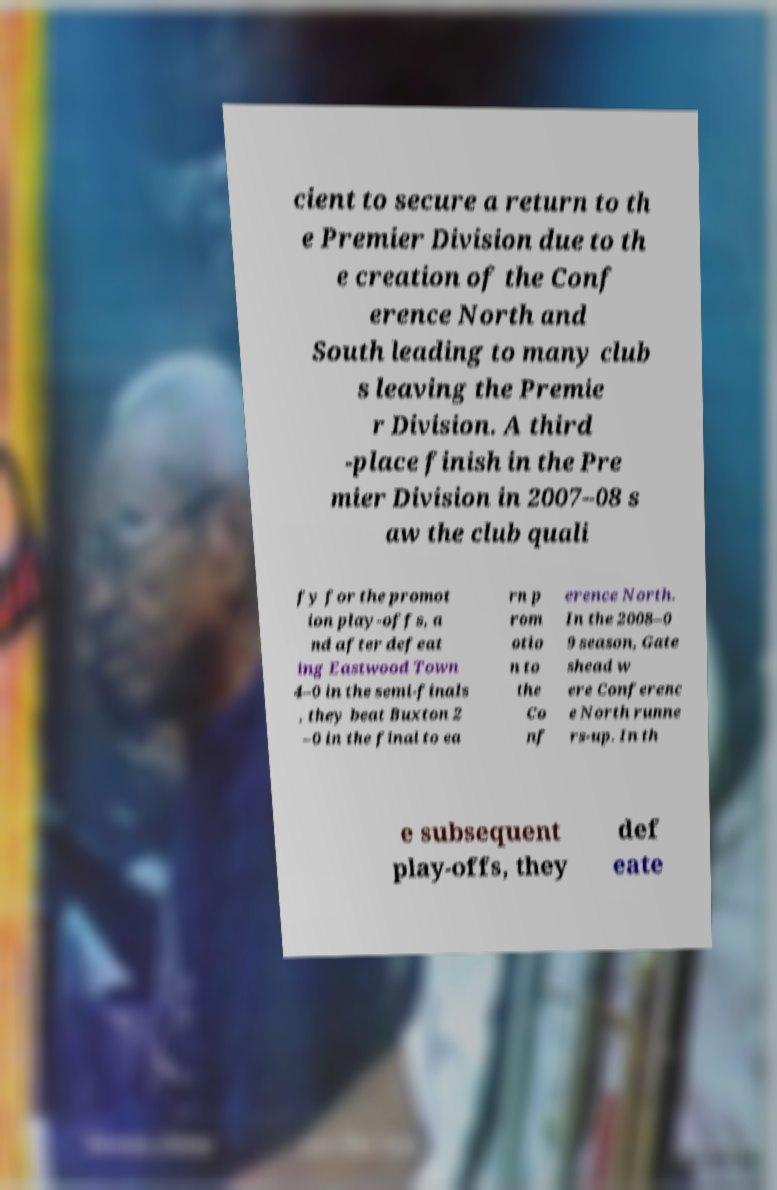Can you read and provide the text displayed in the image?This photo seems to have some interesting text. Can you extract and type it out for me? cient to secure a return to th e Premier Division due to th e creation of the Conf erence North and South leading to many club s leaving the Premie r Division. A third -place finish in the Pre mier Division in 2007–08 s aw the club quali fy for the promot ion play-offs, a nd after defeat ing Eastwood Town 4–0 in the semi-finals , they beat Buxton 2 –0 in the final to ea rn p rom otio n to the Co nf erence North. In the 2008–0 9 season, Gate shead w ere Conferenc e North runne rs-up. In th e subsequent play-offs, they def eate 